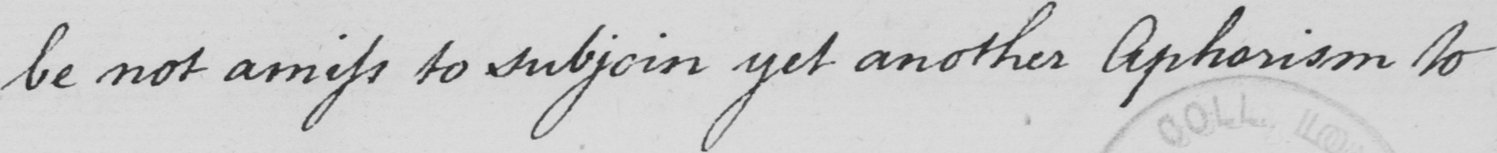What does this handwritten line say? be not amiss to subjoin yet another Aphorism to 